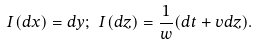Convert formula to latex. <formula><loc_0><loc_0><loc_500><loc_500>I ( d x ) = d y ; \ I ( d z ) = \frac { 1 } { w } ( d t + v d z ) .</formula> 